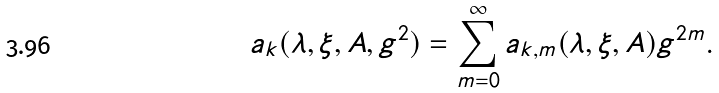<formula> <loc_0><loc_0><loc_500><loc_500>a _ { k } ( \lambda , \xi , A , g ^ { 2 } ) = \sum _ { m = 0 } ^ { \infty } a _ { k , m } ( \lambda , \xi , A ) g ^ { 2 m } .</formula> 